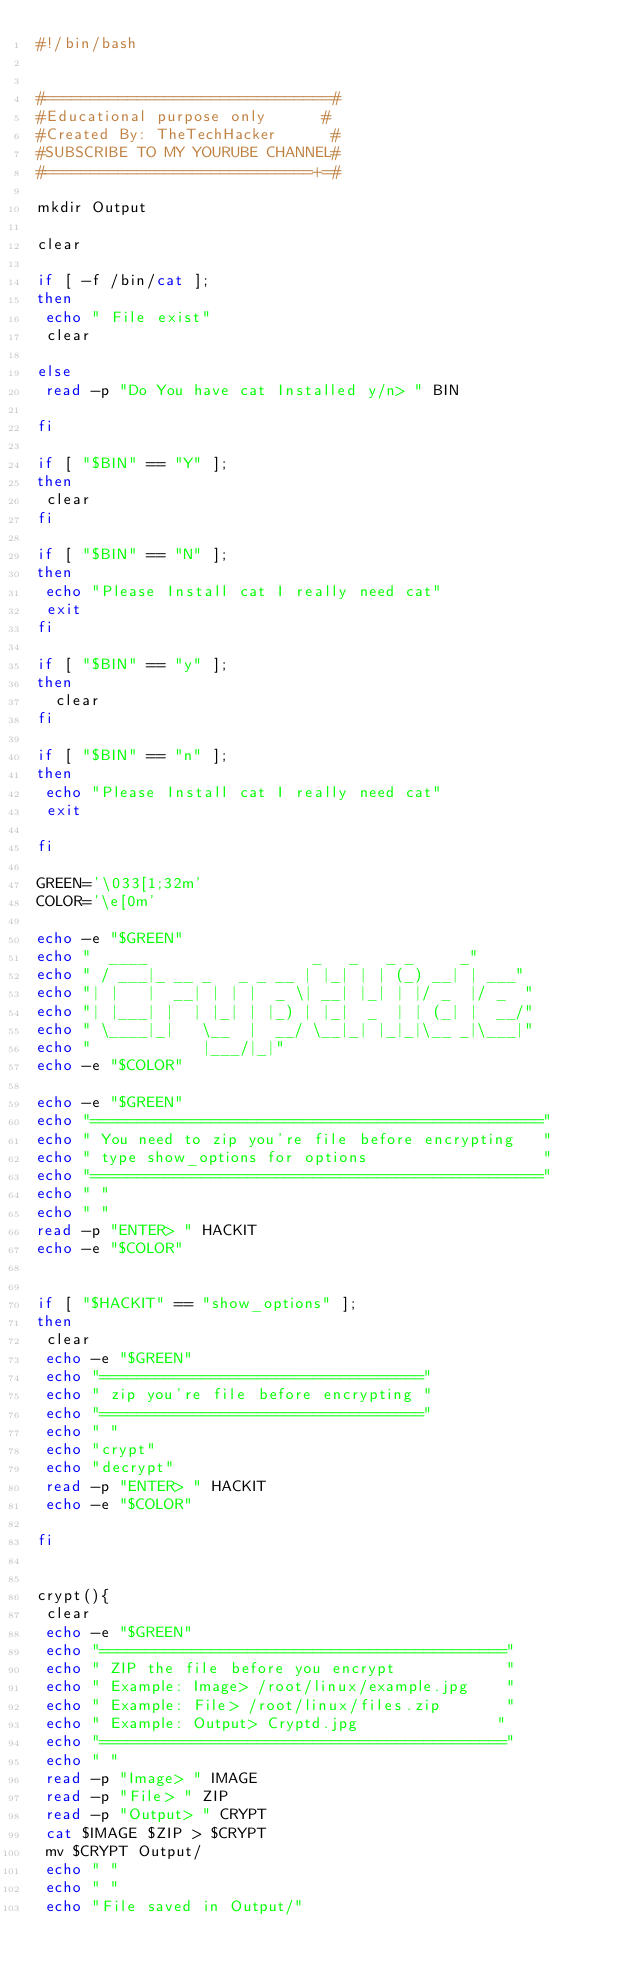<code> <loc_0><loc_0><loc_500><loc_500><_Bash_>#!/bin/bash


#===============================#
#Educational purpose only      #
#Created By: TheTechHacker      #
#SUBSCRIBE TO MY YOURUBE CHANNEL#
#=============================+=#

mkdir Output

clear

if [ -f /bin/cat ];
then
 echo " File exist"
 clear

else
 read -p "Do You have cat Installed y/n> " BIN

fi

if [ "$BIN" == "Y" ];
then
 clear
fi

if [ "$BIN" == "N" ];
then
 echo "Please Install cat I really need cat"
 exit
fi

if [ "$BIN" == "y" ];
then
  clear
fi

if [ "$BIN" == "n" ];
then
 echo "Please Install cat I really need cat"
 exit

fi

GREEN='\033[1;32m'
COLOR='\e[0m'

echo -e "$GREEN"
echo "  ____                  _   _   _ _     _"
echo " / ___|_ __ _   _ _ __ | |_| | | (_) __| | ___"
echo "| |   |  __| | | |  _ \| __| |_| | |/ _  |/ _  "
echo "| |___| |  | |_| | |_) | |_|  _  | | (_| |  __/"
echo " \____|_|   \__  |  __/ \__|_| |_|_|\__ _|\___|"
echo "            |___/|_|"
echo -e "$COLOR"

echo -e "$GREEN"
echo "================================================="
echo " You need to zip you're file before encrypting   "
echo " type show_options for options                   "
echo "================================================="
echo " "
echo " "
read -p "ENTER> " HACKIT
echo -e "$COLOR"


if [ "$HACKIT" == "show_options" ];
then
 clear
 echo -e "$GREEN"
 echo "==================================="
 echo " zip you're file before encrypting "
 echo "==================================="
 echo " "
 echo "crypt"
 echo "decrypt"
 read -p "ENTER> " HACKIT
 echo -e "$COLOR"

fi


crypt(){
 clear
 echo -e "$GREEN"
 echo "============================================"
 echo " ZIP the file before you encrypt            "
 echo " Example: Image> /root/linux/example.jpg    "
 echo " Example: File> /root/linux/files.zip       "
 echo " Example: Output> Cryptd.jpg               "
 echo "============================================"
 echo " "
 read -p "Image> " IMAGE
 read -p "File> " ZIP
 read -p "Output> " CRYPT
 cat $IMAGE $ZIP > $CRYPT
 mv $CRYPT Output/
 echo " "
 echo " "
 echo "File saved in Output/"</code> 